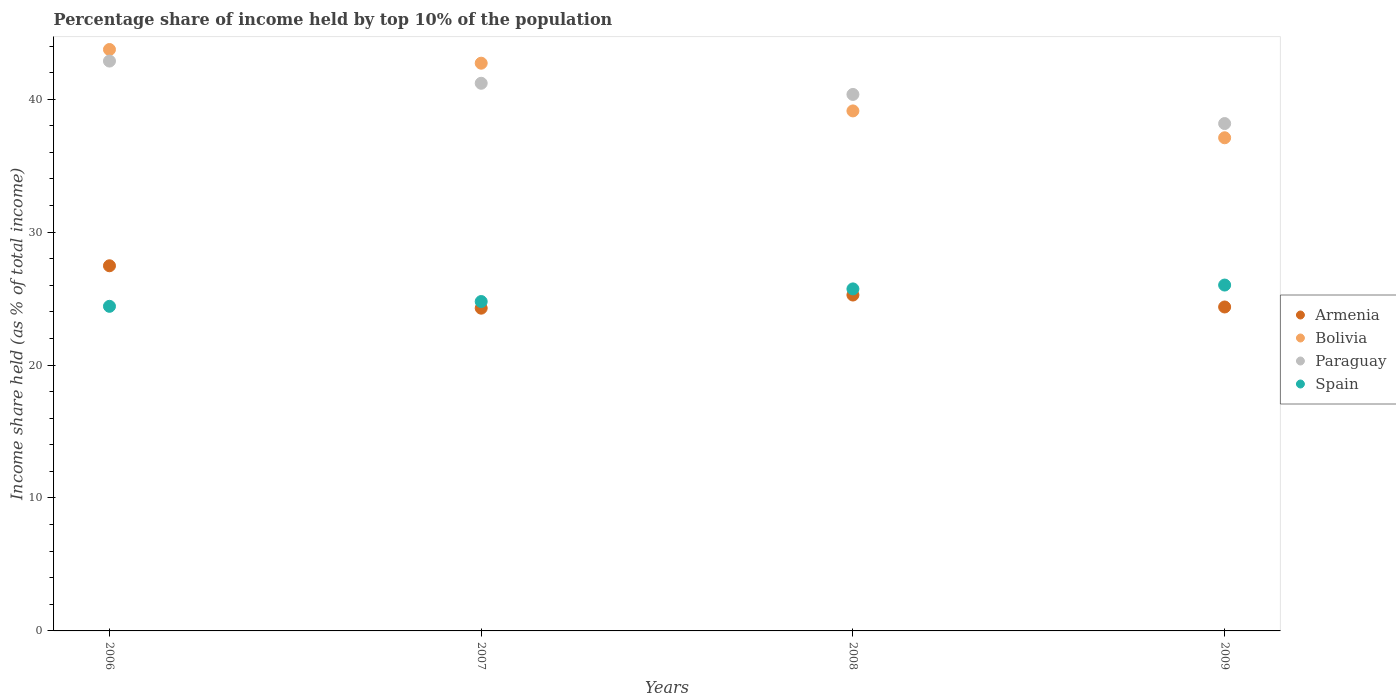What is the percentage share of income held by top 10% of the population in Spain in 2009?
Your answer should be compact. 26.02. Across all years, what is the maximum percentage share of income held by top 10% of the population in Bolivia?
Give a very brief answer. 43.74. Across all years, what is the minimum percentage share of income held by top 10% of the population in Armenia?
Offer a terse response. 24.28. In which year was the percentage share of income held by top 10% of the population in Bolivia minimum?
Keep it short and to the point. 2009. What is the total percentage share of income held by top 10% of the population in Armenia in the graph?
Provide a succinct answer. 101.39. What is the difference between the percentage share of income held by top 10% of the population in Spain in 2006 and that in 2009?
Provide a short and direct response. -1.6. What is the difference between the percentage share of income held by top 10% of the population in Bolivia in 2008 and the percentage share of income held by top 10% of the population in Spain in 2009?
Provide a succinct answer. 13.1. What is the average percentage share of income held by top 10% of the population in Armenia per year?
Your answer should be compact. 25.35. In the year 2006, what is the difference between the percentage share of income held by top 10% of the population in Bolivia and percentage share of income held by top 10% of the population in Spain?
Provide a succinct answer. 19.32. In how many years, is the percentage share of income held by top 10% of the population in Paraguay greater than 30 %?
Your answer should be compact. 4. What is the ratio of the percentage share of income held by top 10% of the population in Spain in 2006 to that in 2007?
Provide a short and direct response. 0.99. Is the percentage share of income held by top 10% of the population in Paraguay in 2007 less than that in 2008?
Your response must be concise. No. What is the difference between the highest and the second highest percentage share of income held by top 10% of the population in Spain?
Your response must be concise. 0.29. What is the difference between the highest and the lowest percentage share of income held by top 10% of the population in Armenia?
Make the answer very short. 3.19. In how many years, is the percentage share of income held by top 10% of the population in Paraguay greater than the average percentage share of income held by top 10% of the population in Paraguay taken over all years?
Your response must be concise. 2. Is it the case that in every year, the sum of the percentage share of income held by top 10% of the population in Armenia and percentage share of income held by top 10% of the population in Paraguay  is greater than the percentage share of income held by top 10% of the population in Spain?
Your response must be concise. Yes. How many years are there in the graph?
Provide a succinct answer. 4. Does the graph contain any zero values?
Your answer should be compact. No. What is the title of the graph?
Your answer should be compact. Percentage share of income held by top 10% of the population. Does "Sub-Saharan Africa (developing only)" appear as one of the legend labels in the graph?
Offer a terse response. No. What is the label or title of the X-axis?
Offer a very short reply. Years. What is the label or title of the Y-axis?
Your response must be concise. Income share held (as % of total income). What is the Income share held (as % of total income) of Armenia in 2006?
Provide a short and direct response. 27.47. What is the Income share held (as % of total income) of Bolivia in 2006?
Give a very brief answer. 43.74. What is the Income share held (as % of total income) in Paraguay in 2006?
Ensure brevity in your answer.  42.87. What is the Income share held (as % of total income) in Spain in 2006?
Give a very brief answer. 24.42. What is the Income share held (as % of total income) of Armenia in 2007?
Your response must be concise. 24.28. What is the Income share held (as % of total income) in Bolivia in 2007?
Your response must be concise. 42.71. What is the Income share held (as % of total income) of Paraguay in 2007?
Your response must be concise. 41.2. What is the Income share held (as % of total income) of Spain in 2007?
Offer a very short reply. 24.78. What is the Income share held (as % of total income) of Armenia in 2008?
Ensure brevity in your answer.  25.27. What is the Income share held (as % of total income) in Bolivia in 2008?
Your answer should be very brief. 39.12. What is the Income share held (as % of total income) of Paraguay in 2008?
Offer a very short reply. 40.36. What is the Income share held (as % of total income) in Spain in 2008?
Give a very brief answer. 25.73. What is the Income share held (as % of total income) of Armenia in 2009?
Provide a succinct answer. 24.37. What is the Income share held (as % of total income) in Bolivia in 2009?
Provide a succinct answer. 37.1. What is the Income share held (as % of total income) of Paraguay in 2009?
Offer a very short reply. 38.17. What is the Income share held (as % of total income) of Spain in 2009?
Keep it short and to the point. 26.02. Across all years, what is the maximum Income share held (as % of total income) in Armenia?
Provide a succinct answer. 27.47. Across all years, what is the maximum Income share held (as % of total income) in Bolivia?
Offer a very short reply. 43.74. Across all years, what is the maximum Income share held (as % of total income) in Paraguay?
Provide a short and direct response. 42.87. Across all years, what is the maximum Income share held (as % of total income) in Spain?
Your answer should be compact. 26.02. Across all years, what is the minimum Income share held (as % of total income) in Armenia?
Keep it short and to the point. 24.28. Across all years, what is the minimum Income share held (as % of total income) of Bolivia?
Give a very brief answer. 37.1. Across all years, what is the minimum Income share held (as % of total income) of Paraguay?
Give a very brief answer. 38.17. Across all years, what is the minimum Income share held (as % of total income) of Spain?
Provide a succinct answer. 24.42. What is the total Income share held (as % of total income) in Armenia in the graph?
Your response must be concise. 101.39. What is the total Income share held (as % of total income) in Bolivia in the graph?
Provide a succinct answer. 162.67. What is the total Income share held (as % of total income) in Paraguay in the graph?
Your answer should be very brief. 162.6. What is the total Income share held (as % of total income) of Spain in the graph?
Offer a very short reply. 100.95. What is the difference between the Income share held (as % of total income) in Armenia in 2006 and that in 2007?
Provide a short and direct response. 3.19. What is the difference between the Income share held (as % of total income) in Bolivia in 2006 and that in 2007?
Give a very brief answer. 1.03. What is the difference between the Income share held (as % of total income) in Paraguay in 2006 and that in 2007?
Offer a terse response. 1.67. What is the difference between the Income share held (as % of total income) in Spain in 2006 and that in 2007?
Offer a terse response. -0.36. What is the difference between the Income share held (as % of total income) in Bolivia in 2006 and that in 2008?
Your response must be concise. 4.62. What is the difference between the Income share held (as % of total income) of Paraguay in 2006 and that in 2008?
Make the answer very short. 2.51. What is the difference between the Income share held (as % of total income) of Spain in 2006 and that in 2008?
Ensure brevity in your answer.  -1.31. What is the difference between the Income share held (as % of total income) of Armenia in 2006 and that in 2009?
Ensure brevity in your answer.  3.1. What is the difference between the Income share held (as % of total income) of Bolivia in 2006 and that in 2009?
Your response must be concise. 6.64. What is the difference between the Income share held (as % of total income) in Armenia in 2007 and that in 2008?
Provide a succinct answer. -0.99. What is the difference between the Income share held (as % of total income) of Bolivia in 2007 and that in 2008?
Your answer should be very brief. 3.59. What is the difference between the Income share held (as % of total income) of Paraguay in 2007 and that in 2008?
Your answer should be compact. 0.84. What is the difference between the Income share held (as % of total income) in Spain in 2007 and that in 2008?
Offer a very short reply. -0.95. What is the difference between the Income share held (as % of total income) of Armenia in 2007 and that in 2009?
Provide a succinct answer. -0.09. What is the difference between the Income share held (as % of total income) in Bolivia in 2007 and that in 2009?
Offer a very short reply. 5.61. What is the difference between the Income share held (as % of total income) of Paraguay in 2007 and that in 2009?
Make the answer very short. 3.03. What is the difference between the Income share held (as % of total income) in Spain in 2007 and that in 2009?
Provide a short and direct response. -1.24. What is the difference between the Income share held (as % of total income) in Armenia in 2008 and that in 2009?
Your answer should be compact. 0.9. What is the difference between the Income share held (as % of total income) in Bolivia in 2008 and that in 2009?
Keep it short and to the point. 2.02. What is the difference between the Income share held (as % of total income) of Paraguay in 2008 and that in 2009?
Give a very brief answer. 2.19. What is the difference between the Income share held (as % of total income) of Spain in 2008 and that in 2009?
Offer a terse response. -0.29. What is the difference between the Income share held (as % of total income) in Armenia in 2006 and the Income share held (as % of total income) in Bolivia in 2007?
Your answer should be compact. -15.24. What is the difference between the Income share held (as % of total income) in Armenia in 2006 and the Income share held (as % of total income) in Paraguay in 2007?
Your answer should be very brief. -13.73. What is the difference between the Income share held (as % of total income) of Armenia in 2006 and the Income share held (as % of total income) of Spain in 2007?
Give a very brief answer. 2.69. What is the difference between the Income share held (as % of total income) in Bolivia in 2006 and the Income share held (as % of total income) in Paraguay in 2007?
Offer a terse response. 2.54. What is the difference between the Income share held (as % of total income) in Bolivia in 2006 and the Income share held (as % of total income) in Spain in 2007?
Make the answer very short. 18.96. What is the difference between the Income share held (as % of total income) of Paraguay in 2006 and the Income share held (as % of total income) of Spain in 2007?
Provide a short and direct response. 18.09. What is the difference between the Income share held (as % of total income) of Armenia in 2006 and the Income share held (as % of total income) of Bolivia in 2008?
Offer a very short reply. -11.65. What is the difference between the Income share held (as % of total income) of Armenia in 2006 and the Income share held (as % of total income) of Paraguay in 2008?
Offer a very short reply. -12.89. What is the difference between the Income share held (as % of total income) of Armenia in 2006 and the Income share held (as % of total income) of Spain in 2008?
Your response must be concise. 1.74. What is the difference between the Income share held (as % of total income) in Bolivia in 2006 and the Income share held (as % of total income) in Paraguay in 2008?
Offer a terse response. 3.38. What is the difference between the Income share held (as % of total income) in Bolivia in 2006 and the Income share held (as % of total income) in Spain in 2008?
Keep it short and to the point. 18.01. What is the difference between the Income share held (as % of total income) in Paraguay in 2006 and the Income share held (as % of total income) in Spain in 2008?
Offer a terse response. 17.14. What is the difference between the Income share held (as % of total income) in Armenia in 2006 and the Income share held (as % of total income) in Bolivia in 2009?
Provide a short and direct response. -9.63. What is the difference between the Income share held (as % of total income) of Armenia in 2006 and the Income share held (as % of total income) of Spain in 2009?
Make the answer very short. 1.45. What is the difference between the Income share held (as % of total income) of Bolivia in 2006 and the Income share held (as % of total income) of Paraguay in 2009?
Keep it short and to the point. 5.57. What is the difference between the Income share held (as % of total income) in Bolivia in 2006 and the Income share held (as % of total income) in Spain in 2009?
Make the answer very short. 17.72. What is the difference between the Income share held (as % of total income) in Paraguay in 2006 and the Income share held (as % of total income) in Spain in 2009?
Keep it short and to the point. 16.85. What is the difference between the Income share held (as % of total income) in Armenia in 2007 and the Income share held (as % of total income) in Bolivia in 2008?
Provide a short and direct response. -14.84. What is the difference between the Income share held (as % of total income) in Armenia in 2007 and the Income share held (as % of total income) in Paraguay in 2008?
Your response must be concise. -16.08. What is the difference between the Income share held (as % of total income) in Armenia in 2007 and the Income share held (as % of total income) in Spain in 2008?
Your answer should be very brief. -1.45. What is the difference between the Income share held (as % of total income) in Bolivia in 2007 and the Income share held (as % of total income) in Paraguay in 2008?
Give a very brief answer. 2.35. What is the difference between the Income share held (as % of total income) of Bolivia in 2007 and the Income share held (as % of total income) of Spain in 2008?
Keep it short and to the point. 16.98. What is the difference between the Income share held (as % of total income) of Paraguay in 2007 and the Income share held (as % of total income) of Spain in 2008?
Keep it short and to the point. 15.47. What is the difference between the Income share held (as % of total income) of Armenia in 2007 and the Income share held (as % of total income) of Bolivia in 2009?
Your answer should be compact. -12.82. What is the difference between the Income share held (as % of total income) in Armenia in 2007 and the Income share held (as % of total income) in Paraguay in 2009?
Keep it short and to the point. -13.89. What is the difference between the Income share held (as % of total income) of Armenia in 2007 and the Income share held (as % of total income) of Spain in 2009?
Provide a short and direct response. -1.74. What is the difference between the Income share held (as % of total income) in Bolivia in 2007 and the Income share held (as % of total income) in Paraguay in 2009?
Give a very brief answer. 4.54. What is the difference between the Income share held (as % of total income) of Bolivia in 2007 and the Income share held (as % of total income) of Spain in 2009?
Give a very brief answer. 16.69. What is the difference between the Income share held (as % of total income) in Paraguay in 2007 and the Income share held (as % of total income) in Spain in 2009?
Your answer should be very brief. 15.18. What is the difference between the Income share held (as % of total income) of Armenia in 2008 and the Income share held (as % of total income) of Bolivia in 2009?
Offer a very short reply. -11.83. What is the difference between the Income share held (as % of total income) of Armenia in 2008 and the Income share held (as % of total income) of Paraguay in 2009?
Your response must be concise. -12.9. What is the difference between the Income share held (as % of total income) of Armenia in 2008 and the Income share held (as % of total income) of Spain in 2009?
Your answer should be compact. -0.75. What is the difference between the Income share held (as % of total income) of Bolivia in 2008 and the Income share held (as % of total income) of Paraguay in 2009?
Your answer should be very brief. 0.95. What is the difference between the Income share held (as % of total income) in Bolivia in 2008 and the Income share held (as % of total income) in Spain in 2009?
Provide a succinct answer. 13.1. What is the difference between the Income share held (as % of total income) of Paraguay in 2008 and the Income share held (as % of total income) of Spain in 2009?
Your response must be concise. 14.34. What is the average Income share held (as % of total income) in Armenia per year?
Provide a short and direct response. 25.35. What is the average Income share held (as % of total income) of Bolivia per year?
Your answer should be very brief. 40.67. What is the average Income share held (as % of total income) of Paraguay per year?
Give a very brief answer. 40.65. What is the average Income share held (as % of total income) of Spain per year?
Provide a succinct answer. 25.24. In the year 2006, what is the difference between the Income share held (as % of total income) of Armenia and Income share held (as % of total income) of Bolivia?
Give a very brief answer. -16.27. In the year 2006, what is the difference between the Income share held (as % of total income) in Armenia and Income share held (as % of total income) in Paraguay?
Give a very brief answer. -15.4. In the year 2006, what is the difference between the Income share held (as % of total income) in Armenia and Income share held (as % of total income) in Spain?
Offer a terse response. 3.05. In the year 2006, what is the difference between the Income share held (as % of total income) in Bolivia and Income share held (as % of total income) in Paraguay?
Offer a terse response. 0.87. In the year 2006, what is the difference between the Income share held (as % of total income) in Bolivia and Income share held (as % of total income) in Spain?
Provide a short and direct response. 19.32. In the year 2006, what is the difference between the Income share held (as % of total income) of Paraguay and Income share held (as % of total income) of Spain?
Offer a very short reply. 18.45. In the year 2007, what is the difference between the Income share held (as % of total income) of Armenia and Income share held (as % of total income) of Bolivia?
Make the answer very short. -18.43. In the year 2007, what is the difference between the Income share held (as % of total income) in Armenia and Income share held (as % of total income) in Paraguay?
Your answer should be very brief. -16.92. In the year 2007, what is the difference between the Income share held (as % of total income) of Armenia and Income share held (as % of total income) of Spain?
Ensure brevity in your answer.  -0.5. In the year 2007, what is the difference between the Income share held (as % of total income) in Bolivia and Income share held (as % of total income) in Paraguay?
Offer a very short reply. 1.51. In the year 2007, what is the difference between the Income share held (as % of total income) in Bolivia and Income share held (as % of total income) in Spain?
Offer a terse response. 17.93. In the year 2007, what is the difference between the Income share held (as % of total income) in Paraguay and Income share held (as % of total income) in Spain?
Provide a short and direct response. 16.42. In the year 2008, what is the difference between the Income share held (as % of total income) in Armenia and Income share held (as % of total income) in Bolivia?
Your answer should be compact. -13.85. In the year 2008, what is the difference between the Income share held (as % of total income) of Armenia and Income share held (as % of total income) of Paraguay?
Offer a terse response. -15.09. In the year 2008, what is the difference between the Income share held (as % of total income) in Armenia and Income share held (as % of total income) in Spain?
Make the answer very short. -0.46. In the year 2008, what is the difference between the Income share held (as % of total income) of Bolivia and Income share held (as % of total income) of Paraguay?
Offer a very short reply. -1.24. In the year 2008, what is the difference between the Income share held (as % of total income) in Bolivia and Income share held (as % of total income) in Spain?
Make the answer very short. 13.39. In the year 2008, what is the difference between the Income share held (as % of total income) in Paraguay and Income share held (as % of total income) in Spain?
Give a very brief answer. 14.63. In the year 2009, what is the difference between the Income share held (as % of total income) of Armenia and Income share held (as % of total income) of Bolivia?
Offer a terse response. -12.73. In the year 2009, what is the difference between the Income share held (as % of total income) of Armenia and Income share held (as % of total income) of Paraguay?
Ensure brevity in your answer.  -13.8. In the year 2009, what is the difference between the Income share held (as % of total income) in Armenia and Income share held (as % of total income) in Spain?
Offer a very short reply. -1.65. In the year 2009, what is the difference between the Income share held (as % of total income) of Bolivia and Income share held (as % of total income) of Paraguay?
Provide a succinct answer. -1.07. In the year 2009, what is the difference between the Income share held (as % of total income) in Bolivia and Income share held (as % of total income) in Spain?
Offer a very short reply. 11.08. In the year 2009, what is the difference between the Income share held (as % of total income) in Paraguay and Income share held (as % of total income) in Spain?
Give a very brief answer. 12.15. What is the ratio of the Income share held (as % of total income) in Armenia in 2006 to that in 2007?
Your answer should be very brief. 1.13. What is the ratio of the Income share held (as % of total income) of Bolivia in 2006 to that in 2007?
Provide a short and direct response. 1.02. What is the ratio of the Income share held (as % of total income) in Paraguay in 2006 to that in 2007?
Your answer should be very brief. 1.04. What is the ratio of the Income share held (as % of total income) in Spain in 2006 to that in 2007?
Make the answer very short. 0.99. What is the ratio of the Income share held (as % of total income) of Armenia in 2006 to that in 2008?
Keep it short and to the point. 1.09. What is the ratio of the Income share held (as % of total income) in Bolivia in 2006 to that in 2008?
Ensure brevity in your answer.  1.12. What is the ratio of the Income share held (as % of total income) of Paraguay in 2006 to that in 2008?
Your answer should be very brief. 1.06. What is the ratio of the Income share held (as % of total income) in Spain in 2006 to that in 2008?
Offer a very short reply. 0.95. What is the ratio of the Income share held (as % of total income) in Armenia in 2006 to that in 2009?
Ensure brevity in your answer.  1.13. What is the ratio of the Income share held (as % of total income) in Bolivia in 2006 to that in 2009?
Offer a very short reply. 1.18. What is the ratio of the Income share held (as % of total income) in Paraguay in 2006 to that in 2009?
Your answer should be very brief. 1.12. What is the ratio of the Income share held (as % of total income) in Spain in 2006 to that in 2009?
Make the answer very short. 0.94. What is the ratio of the Income share held (as % of total income) of Armenia in 2007 to that in 2008?
Offer a terse response. 0.96. What is the ratio of the Income share held (as % of total income) of Bolivia in 2007 to that in 2008?
Make the answer very short. 1.09. What is the ratio of the Income share held (as % of total income) of Paraguay in 2007 to that in 2008?
Make the answer very short. 1.02. What is the ratio of the Income share held (as % of total income) in Spain in 2007 to that in 2008?
Keep it short and to the point. 0.96. What is the ratio of the Income share held (as % of total income) of Armenia in 2007 to that in 2009?
Make the answer very short. 1. What is the ratio of the Income share held (as % of total income) of Bolivia in 2007 to that in 2009?
Offer a very short reply. 1.15. What is the ratio of the Income share held (as % of total income) of Paraguay in 2007 to that in 2009?
Provide a short and direct response. 1.08. What is the ratio of the Income share held (as % of total income) in Spain in 2007 to that in 2009?
Give a very brief answer. 0.95. What is the ratio of the Income share held (as % of total income) in Armenia in 2008 to that in 2009?
Offer a very short reply. 1.04. What is the ratio of the Income share held (as % of total income) of Bolivia in 2008 to that in 2009?
Your answer should be compact. 1.05. What is the ratio of the Income share held (as % of total income) of Paraguay in 2008 to that in 2009?
Give a very brief answer. 1.06. What is the ratio of the Income share held (as % of total income) in Spain in 2008 to that in 2009?
Provide a succinct answer. 0.99. What is the difference between the highest and the second highest Income share held (as % of total income) of Armenia?
Provide a succinct answer. 2.2. What is the difference between the highest and the second highest Income share held (as % of total income) of Bolivia?
Provide a short and direct response. 1.03. What is the difference between the highest and the second highest Income share held (as % of total income) of Paraguay?
Provide a short and direct response. 1.67. What is the difference between the highest and the second highest Income share held (as % of total income) of Spain?
Offer a terse response. 0.29. What is the difference between the highest and the lowest Income share held (as % of total income) of Armenia?
Offer a very short reply. 3.19. What is the difference between the highest and the lowest Income share held (as % of total income) in Bolivia?
Your answer should be very brief. 6.64. 